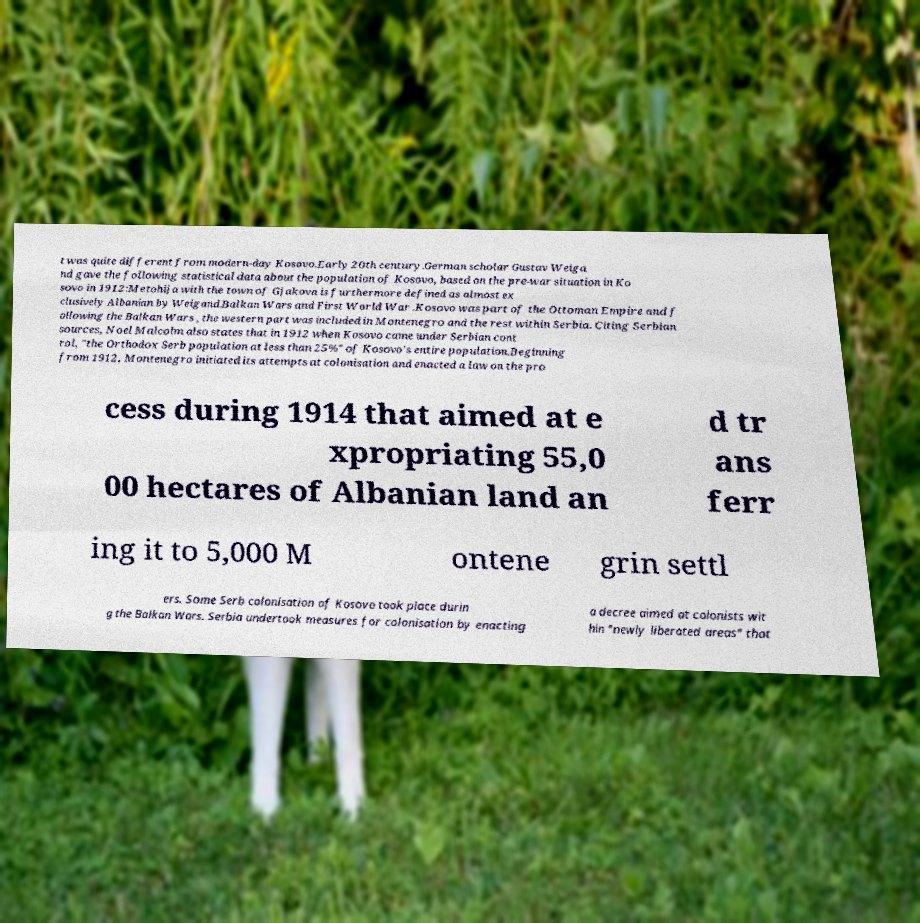Please identify and transcribe the text found in this image. t was quite different from modern-day Kosovo.Early 20th century.German scholar Gustav Weiga nd gave the following statistical data about the population of Kosovo, based on the pre-war situation in Ko sovo in 1912:Metohija with the town of Gjakova is furthermore defined as almost ex clusively Albanian by Weigand.Balkan Wars and First World War .Kosovo was part of the Ottoman Empire and f ollowing the Balkan Wars , the western part was included in Montenegro and the rest within Serbia. Citing Serbian sources, Noel Malcolm also states that in 1912 when Kosovo came under Serbian cont rol, "the Orthodox Serb population at less than 25%" of Kosovo's entire population.Beginning from 1912, Montenegro initiated its attempts at colonisation and enacted a law on the pro cess during 1914 that aimed at e xpropriating 55,0 00 hectares of Albanian land an d tr ans ferr ing it to 5,000 M ontene grin settl ers. Some Serb colonisation of Kosovo took place durin g the Balkan Wars. Serbia undertook measures for colonisation by enacting a decree aimed at colonists wit hin "newly liberated areas" that 